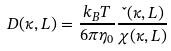Convert formula to latex. <formula><loc_0><loc_0><loc_500><loc_500>D ( \kappa , L ) = \frac { k _ { B } T } { 6 \pi \eta _ { 0 } } \frac { \L ( \kappa , L ) } { \chi ( \kappa , L ) }</formula> 